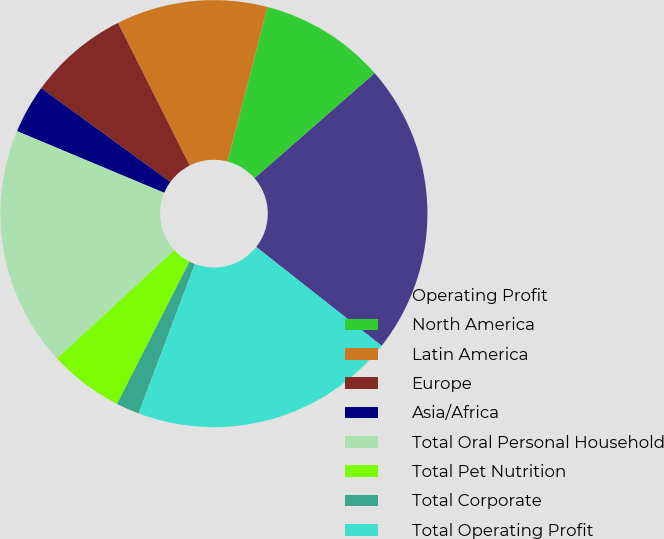<chart> <loc_0><loc_0><loc_500><loc_500><pie_chart><fcel>Operating Profit<fcel>North America<fcel>Latin America<fcel>Europe<fcel>Asia/Africa<fcel>Total Oral Personal Household<fcel>Total Pet Nutrition<fcel>Total Corporate<fcel>Total Operating Profit<nl><fcel>22.06%<fcel>9.52%<fcel>11.46%<fcel>7.58%<fcel>3.69%<fcel>18.18%<fcel>5.64%<fcel>1.75%<fcel>20.12%<nl></chart> 